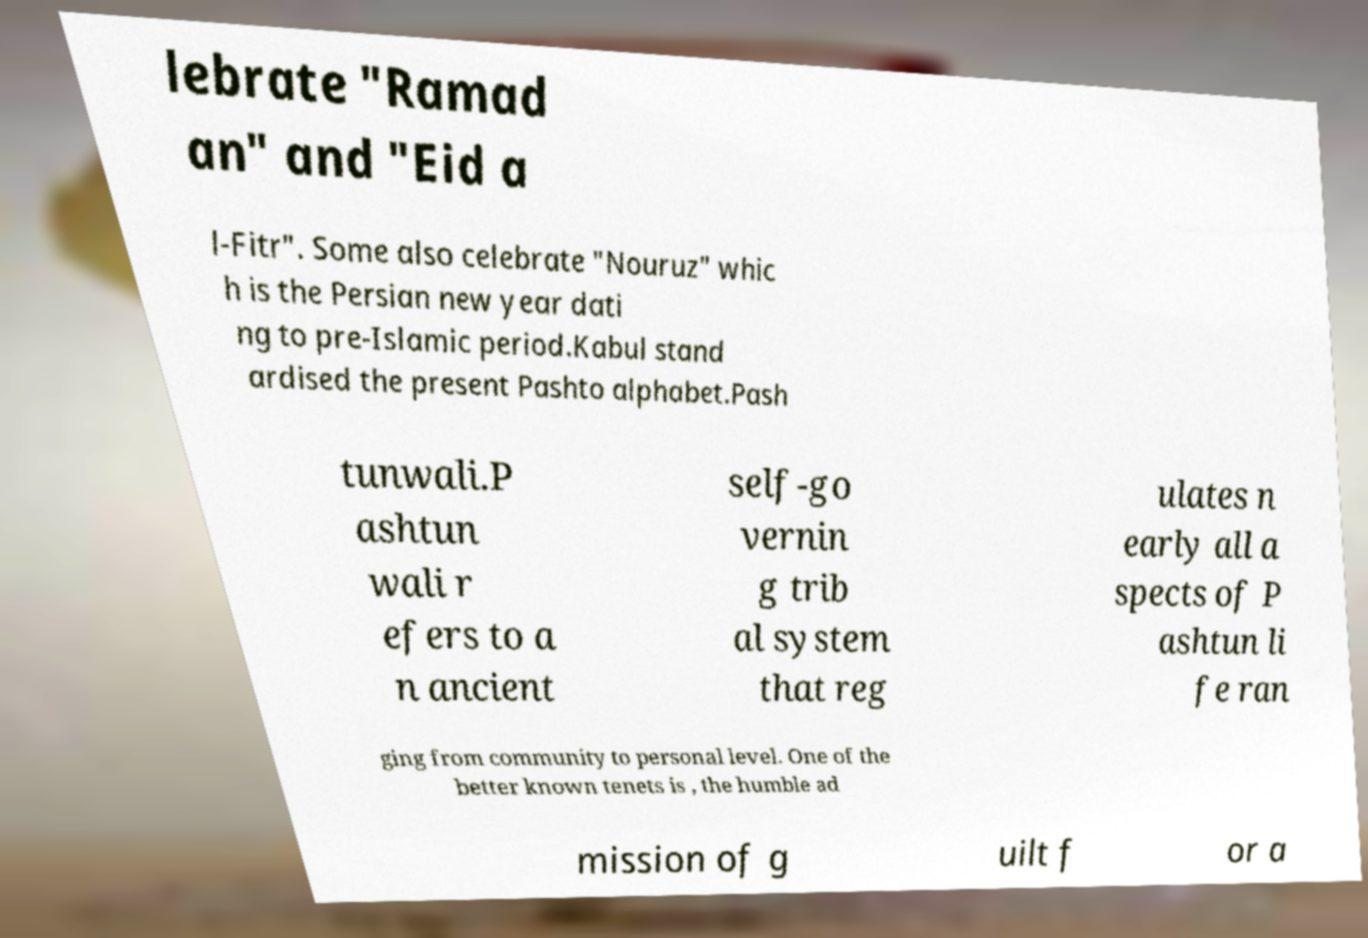There's text embedded in this image that I need extracted. Can you transcribe it verbatim? lebrate "Ramad an" and "Eid a l-Fitr". Some also celebrate "Nouruz" whic h is the Persian new year dati ng to pre-Islamic period.Kabul stand ardised the present Pashto alphabet.Pash tunwali.P ashtun wali r efers to a n ancient self-go vernin g trib al system that reg ulates n early all a spects of P ashtun li fe ran ging from community to personal level. One of the better known tenets is , the humble ad mission of g uilt f or a 